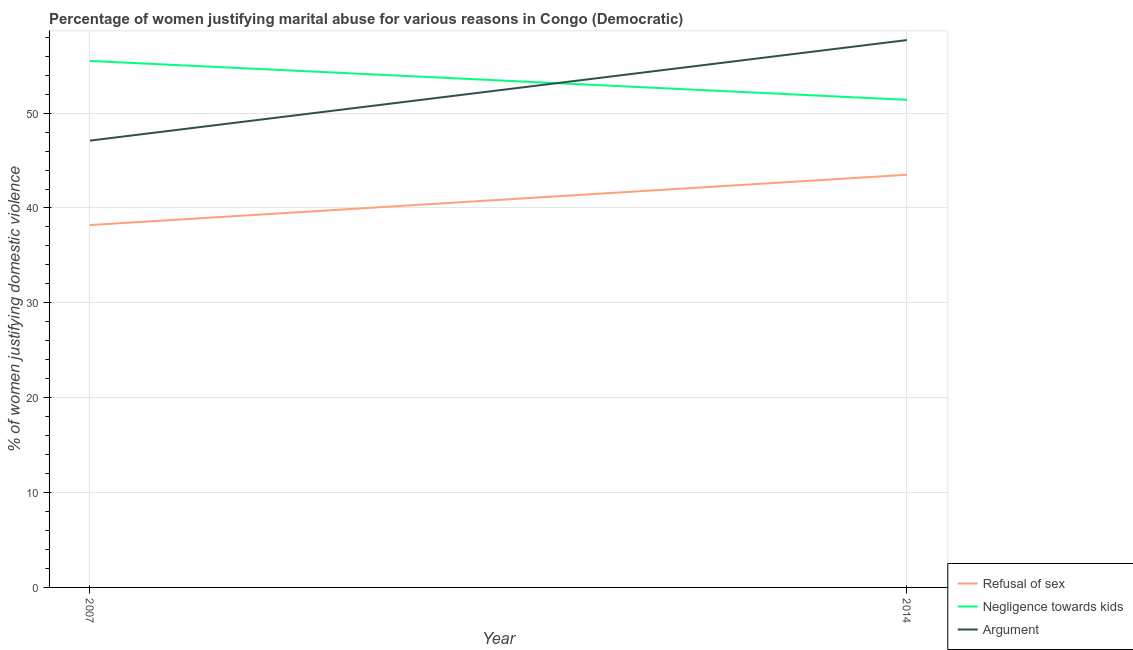Is the number of lines equal to the number of legend labels?
Provide a succinct answer. Yes. What is the percentage of women justifying domestic violence due to arguments in 2014?
Offer a terse response. 57.7. Across all years, what is the maximum percentage of women justifying domestic violence due to arguments?
Make the answer very short. 57.7. Across all years, what is the minimum percentage of women justifying domestic violence due to negligence towards kids?
Offer a very short reply. 51.4. In which year was the percentage of women justifying domestic violence due to arguments maximum?
Offer a very short reply. 2014. In which year was the percentage of women justifying domestic violence due to arguments minimum?
Provide a short and direct response. 2007. What is the total percentage of women justifying domestic violence due to refusal of sex in the graph?
Offer a very short reply. 81.7. What is the difference between the percentage of women justifying domestic violence due to arguments in 2007 and that in 2014?
Your response must be concise. -10.6. What is the difference between the percentage of women justifying domestic violence due to arguments in 2007 and the percentage of women justifying domestic violence due to refusal of sex in 2014?
Provide a short and direct response. 3.6. What is the average percentage of women justifying domestic violence due to arguments per year?
Provide a short and direct response. 52.4. In the year 2014, what is the difference between the percentage of women justifying domestic violence due to negligence towards kids and percentage of women justifying domestic violence due to arguments?
Ensure brevity in your answer.  -6.3. What is the ratio of the percentage of women justifying domestic violence due to arguments in 2007 to that in 2014?
Ensure brevity in your answer.  0.82. Is the percentage of women justifying domestic violence due to negligence towards kids in 2007 less than that in 2014?
Your response must be concise. No. In how many years, is the percentage of women justifying domestic violence due to negligence towards kids greater than the average percentage of women justifying domestic violence due to negligence towards kids taken over all years?
Give a very brief answer. 1. Is the percentage of women justifying domestic violence due to refusal of sex strictly greater than the percentage of women justifying domestic violence due to arguments over the years?
Your answer should be compact. No. How many years are there in the graph?
Provide a short and direct response. 2. What is the difference between two consecutive major ticks on the Y-axis?
Give a very brief answer. 10. Are the values on the major ticks of Y-axis written in scientific E-notation?
Provide a succinct answer. No. Does the graph contain any zero values?
Provide a succinct answer. No. Does the graph contain grids?
Your response must be concise. Yes. What is the title of the graph?
Your answer should be compact. Percentage of women justifying marital abuse for various reasons in Congo (Democratic). What is the label or title of the X-axis?
Your answer should be very brief. Year. What is the label or title of the Y-axis?
Your answer should be compact. % of women justifying domestic violence. What is the % of women justifying domestic violence of Refusal of sex in 2007?
Provide a short and direct response. 38.2. What is the % of women justifying domestic violence of Negligence towards kids in 2007?
Ensure brevity in your answer.  55.5. What is the % of women justifying domestic violence of Argument in 2007?
Make the answer very short. 47.1. What is the % of women justifying domestic violence of Refusal of sex in 2014?
Offer a terse response. 43.5. What is the % of women justifying domestic violence in Negligence towards kids in 2014?
Your answer should be compact. 51.4. What is the % of women justifying domestic violence in Argument in 2014?
Offer a terse response. 57.7. Across all years, what is the maximum % of women justifying domestic violence in Refusal of sex?
Give a very brief answer. 43.5. Across all years, what is the maximum % of women justifying domestic violence of Negligence towards kids?
Make the answer very short. 55.5. Across all years, what is the maximum % of women justifying domestic violence in Argument?
Keep it short and to the point. 57.7. Across all years, what is the minimum % of women justifying domestic violence of Refusal of sex?
Ensure brevity in your answer.  38.2. Across all years, what is the minimum % of women justifying domestic violence of Negligence towards kids?
Your answer should be very brief. 51.4. Across all years, what is the minimum % of women justifying domestic violence of Argument?
Keep it short and to the point. 47.1. What is the total % of women justifying domestic violence of Refusal of sex in the graph?
Make the answer very short. 81.7. What is the total % of women justifying domestic violence of Negligence towards kids in the graph?
Make the answer very short. 106.9. What is the total % of women justifying domestic violence of Argument in the graph?
Provide a succinct answer. 104.8. What is the difference between the % of women justifying domestic violence of Argument in 2007 and that in 2014?
Make the answer very short. -10.6. What is the difference between the % of women justifying domestic violence in Refusal of sex in 2007 and the % of women justifying domestic violence in Negligence towards kids in 2014?
Offer a very short reply. -13.2. What is the difference between the % of women justifying domestic violence of Refusal of sex in 2007 and the % of women justifying domestic violence of Argument in 2014?
Your answer should be compact. -19.5. What is the difference between the % of women justifying domestic violence in Negligence towards kids in 2007 and the % of women justifying domestic violence in Argument in 2014?
Offer a very short reply. -2.2. What is the average % of women justifying domestic violence of Refusal of sex per year?
Make the answer very short. 40.85. What is the average % of women justifying domestic violence in Negligence towards kids per year?
Your answer should be very brief. 53.45. What is the average % of women justifying domestic violence of Argument per year?
Your answer should be compact. 52.4. In the year 2007, what is the difference between the % of women justifying domestic violence in Refusal of sex and % of women justifying domestic violence in Negligence towards kids?
Provide a short and direct response. -17.3. In the year 2007, what is the difference between the % of women justifying domestic violence of Refusal of sex and % of women justifying domestic violence of Argument?
Keep it short and to the point. -8.9. In the year 2014, what is the difference between the % of women justifying domestic violence in Refusal of sex and % of women justifying domestic violence in Negligence towards kids?
Provide a succinct answer. -7.9. In the year 2014, what is the difference between the % of women justifying domestic violence of Negligence towards kids and % of women justifying domestic violence of Argument?
Give a very brief answer. -6.3. What is the ratio of the % of women justifying domestic violence in Refusal of sex in 2007 to that in 2014?
Ensure brevity in your answer.  0.88. What is the ratio of the % of women justifying domestic violence in Negligence towards kids in 2007 to that in 2014?
Give a very brief answer. 1.08. What is the ratio of the % of women justifying domestic violence of Argument in 2007 to that in 2014?
Provide a short and direct response. 0.82. What is the difference between the highest and the second highest % of women justifying domestic violence of Argument?
Provide a short and direct response. 10.6. What is the difference between the highest and the lowest % of women justifying domestic violence in Refusal of sex?
Provide a short and direct response. 5.3. What is the difference between the highest and the lowest % of women justifying domestic violence of Negligence towards kids?
Offer a very short reply. 4.1. What is the difference between the highest and the lowest % of women justifying domestic violence in Argument?
Provide a short and direct response. 10.6. 